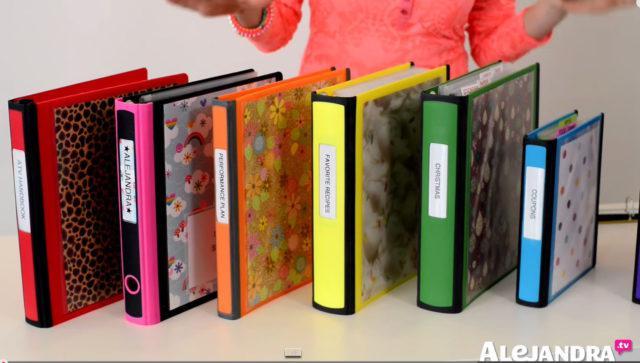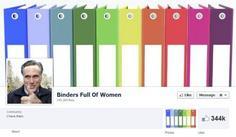The first image is the image on the left, the second image is the image on the right. Analyze the images presented: Is the assertion "There are shelves in the image on the right" valid? Answer yes or no. No. The first image is the image on the left, the second image is the image on the right. Considering the images on both sides, is "At least one image shows a single row of colored binders with white rectangular labels." valid? Answer yes or no. Yes. 